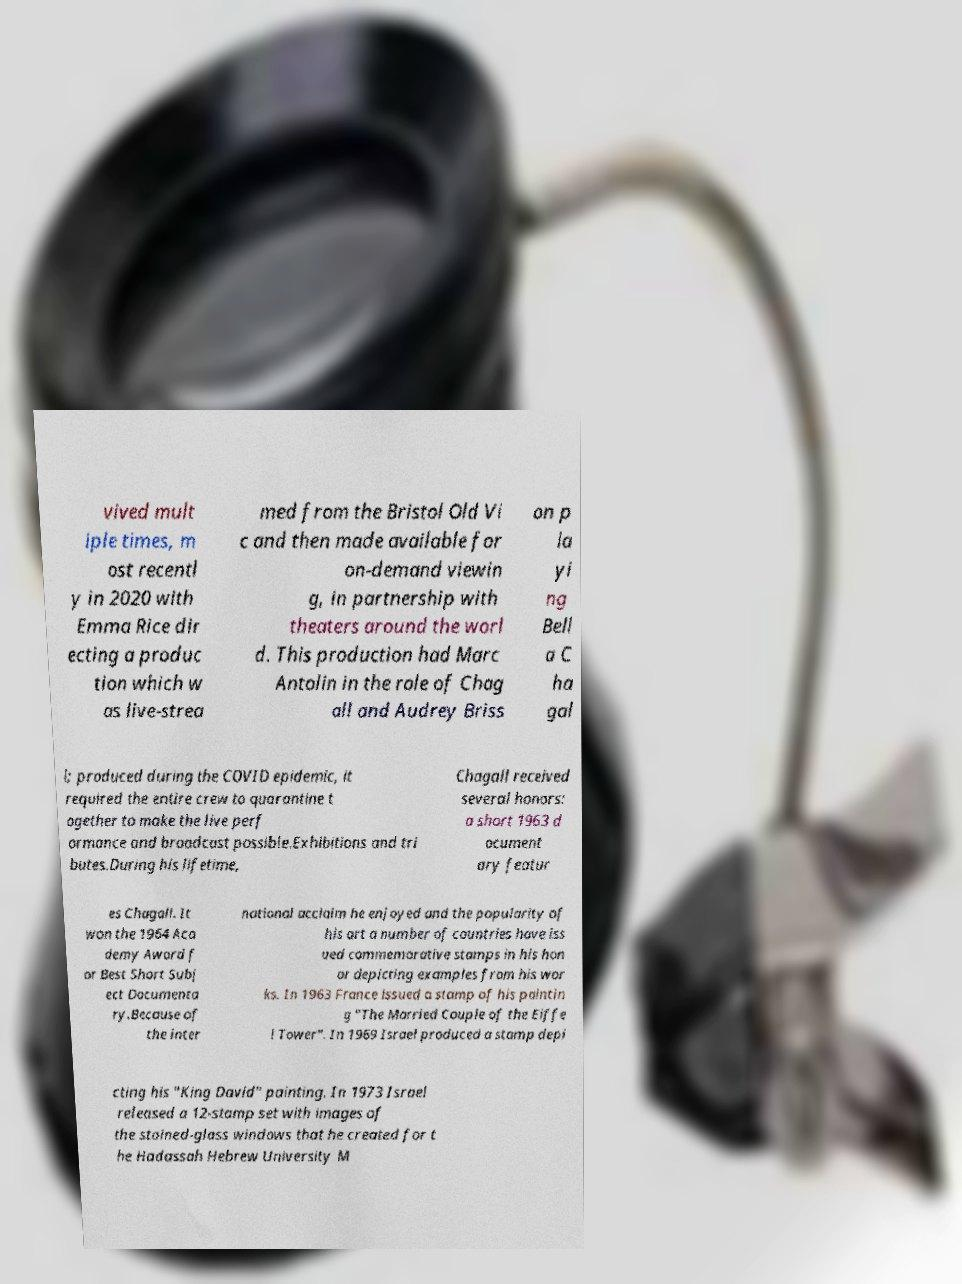Can you accurately transcribe the text from the provided image for me? vived mult iple times, m ost recentl y in 2020 with Emma Rice dir ecting a produc tion which w as live-strea med from the Bristol Old Vi c and then made available for on-demand viewin g, in partnership with theaters around the worl d. This production had Marc Antolin in the role of Chag all and Audrey Briss on p la yi ng Bell a C ha gal l; produced during the COVID epidemic, it required the entire crew to quarantine t ogether to make the live perf ormance and broadcast possible.Exhibitions and tri butes.During his lifetime, Chagall received several honors: a short 1963 d ocument ary featur es Chagall. It won the 1964 Aca demy Award f or Best Short Subj ect Documenta ry.Because of the inter national acclaim he enjoyed and the popularity of his art a number of countries have iss ued commemorative stamps in his hon or depicting examples from his wor ks. In 1963 France issued a stamp of his paintin g "The Married Couple of the Eiffe l Tower". In 1969 Israel produced a stamp depi cting his "King David" painting. In 1973 Israel released a 12-stamp set with images of the stained-glass windows that he created for t he Hadassah Hebrew University M 